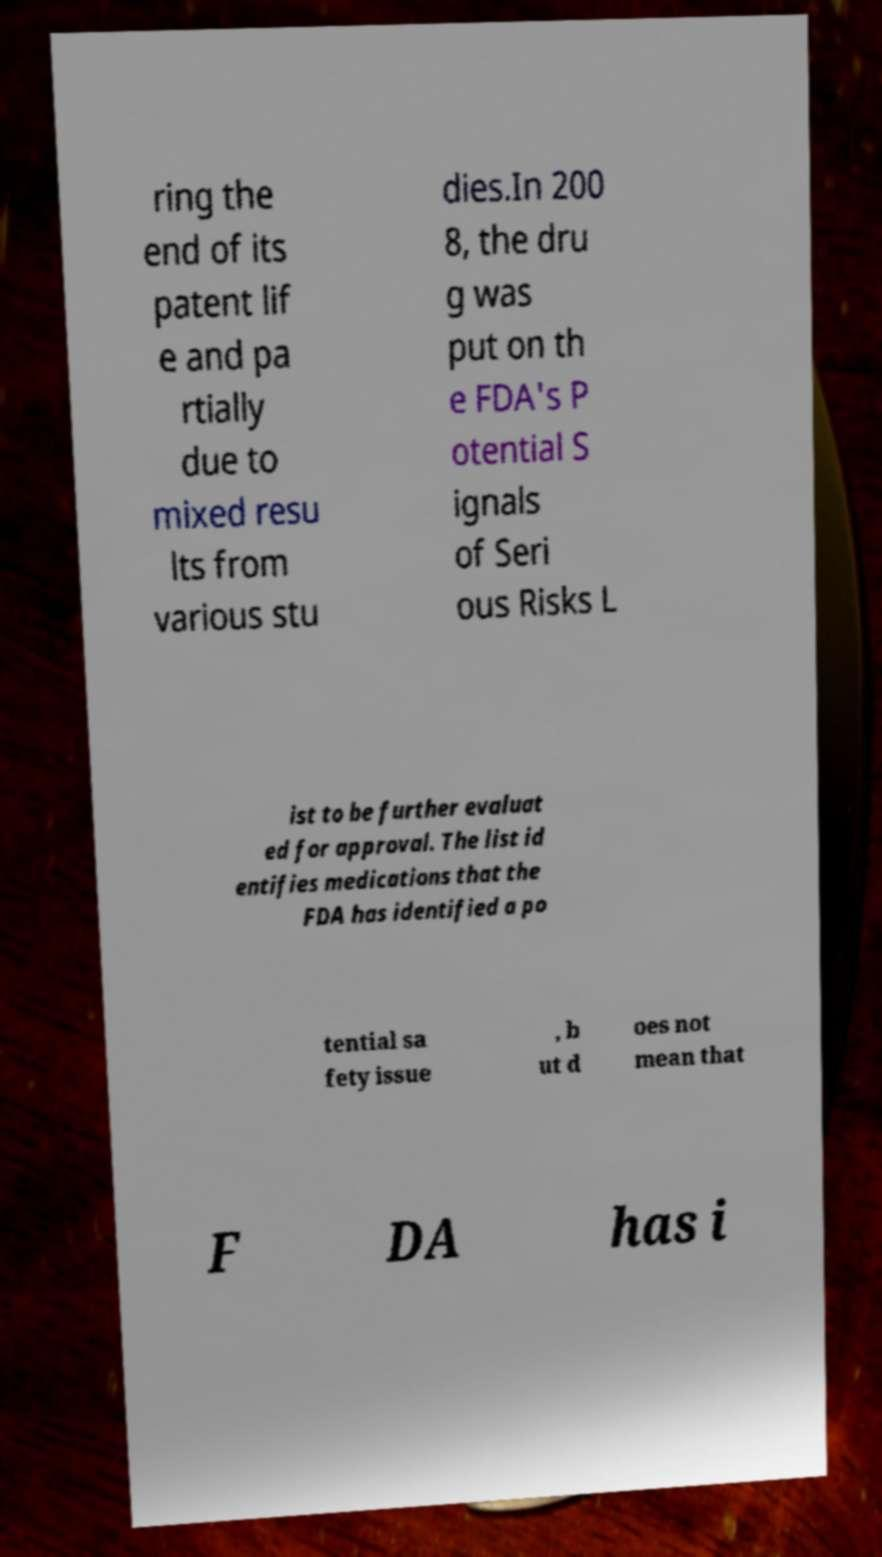I need the written content from this picture converted into text. Can you do that? ring the end of its patent lif e and pa rtially due to mixed resu lts from various stu dies.In 200 8, the dru g was put on th e FDA's P otential S ignals of Seri ous Risks L ist to be further evaluat ed for approval. The list id entifies medications that the FDA has identified a po tential sa fety issue , b ut d oes not mean that F DA has i 